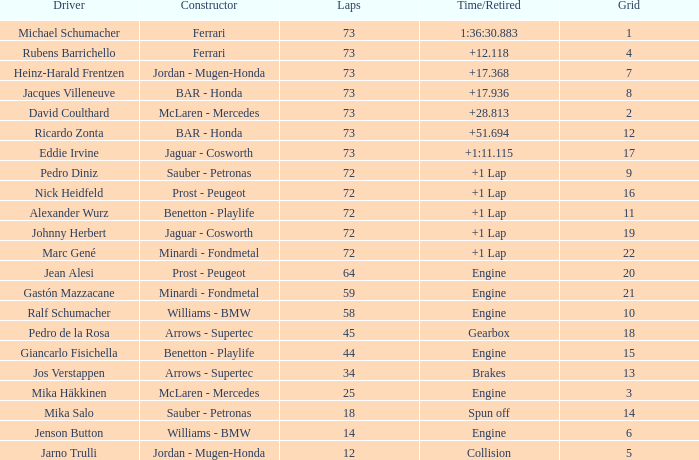How many laps did Jos Verstappen do on Grid 2? 34.0. 